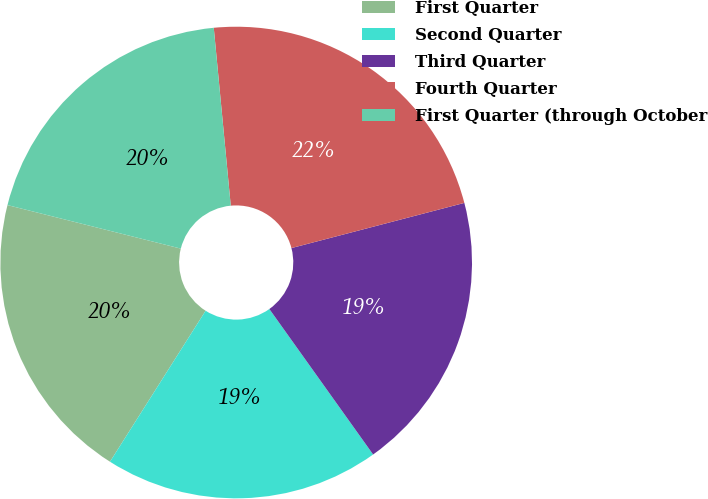Convert chart. <chart><loc_0><loc_0><loc_500><loc_500><pie_chart><fcel>First Quarter<fcel>Second Quarter<fcel>Third Quarter<fcel>Fourth Quarter<fcel>First Quarter (through October<nl><fcel>19.93%<fcel>18.85%<fcel>19.21%<fcel>22.45%<fcel>19.57%<nl></chart> 